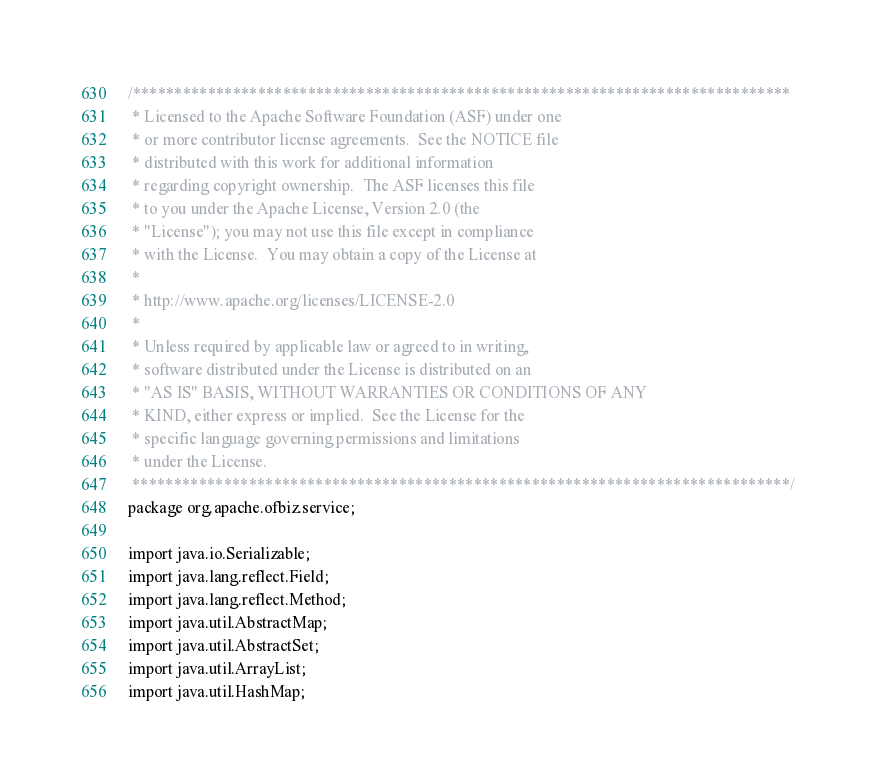<code> <loc_0><loc_0><loc_500><loc_500><_Java_>/*******************************************************************************
 * Licensed to the Apache Software Foundation (ASF) under one
 * or more contributor license agreements.  See the NOTICE file
 * distributed with this work for additional information
 * regarding copyright ownership.  The ASF licenses this file
 * to you under the Apache License, Version 2.0 (the
 * "License"); you may not use this file except in compliance
 * with the License.  You may obtain a copy of the License at
 *
 * http://www.apache.org/licenses/LICENSE-2.0
 *
 * Unless required by applicable law or agreed to in writing,
 * software distributed under the License is distributed on an
 * "AS IS" BASIS, WITHOUT WARRANTIES OR CONDITIONS OF ANY
 * KIND, either express or implied.  See the License for the
 * specific language governing permissions and limitations
 * under the License.
 *******************************************************************************/
package org.apache.ofbiz.service;

import java.io.Serializable;
import java.lang.reflect.Field;
import java.lang.reflect.Method;
import java.util.AbstractMap;
import java.util.AbstractSet;
import java.util.ArrayList;
import java.util.HashMap;</code> 